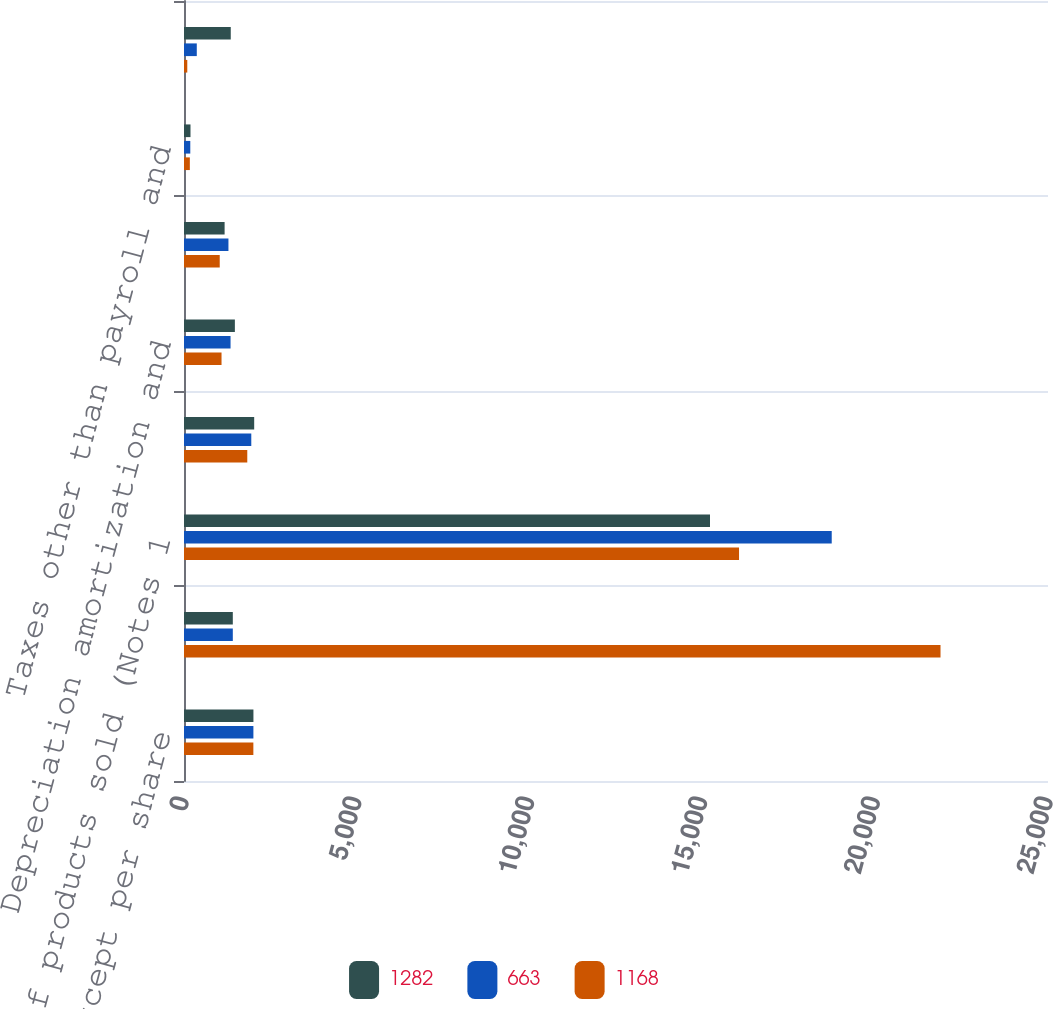Convert chart. <chart><loc_0><loc_0><loc_500><loc_500><stacked_bar_chart><ecel><fcel>In millions except per share<fcel>NET SALES<fcel>Cost of products sold (Notes 1<fcel>Selling and administrative<fcel>Depreciation amortization and<fcel>Distribution expenses<fcel>Taxes other than payroll and<fcel>Restructuring and other<nl><fcel>1282<fcel>2009<fcel>1412.5<fcel>15220<fcel>2031<fcel>1472<fcel>1175<fcel>188<fcel>1353<nl><fcel>663<fcel>2008<fcel>1412.5<fcel>18742<fcel>1947<fcel>1347<fcel>1286<fcel>182<fcel>370<nl><fcel>1168<fcel>2007<fcel>21890<fcel>16060<fcel>1831<fcel>1086<fcel>1034<fcel>169<fcel>95<nl></chart> 